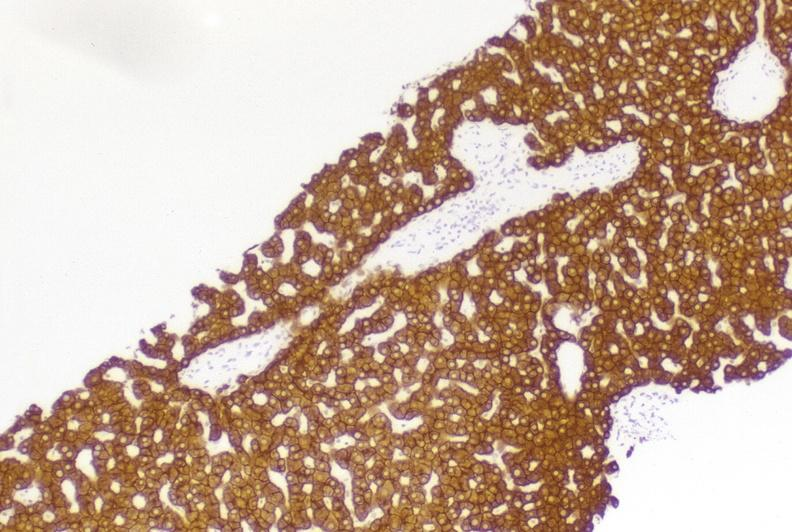what is present?
Answer the question using a single word or phrase. Hepatobiliary 